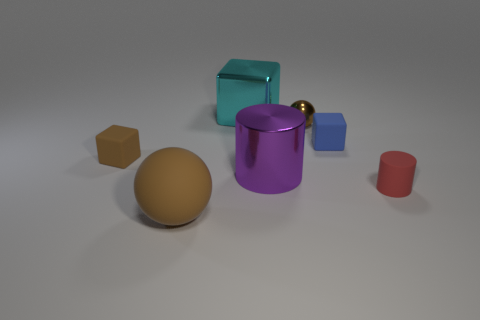Add 3 metallic objects. How many objects exist? 10 Subtract all cylinders. How many objects are left? 5 Add 7 brown balls. How many brown balls are left? 9 Add 7 blue rubber cubes. How many blue rubber cubes exist? 8 Subtract 0 gray cylinders. How many objects are left? 7 Subtract all brown blocks. Subtract all large gray metallic objects. How many objects are left? 6 